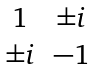Convert formula to latex. <formula><loc_0><loc_0><loc_500><loc_500>\begin{matrix} 1 & \pm i \\ \pm i & - 1 \end{matrix}</formula> 